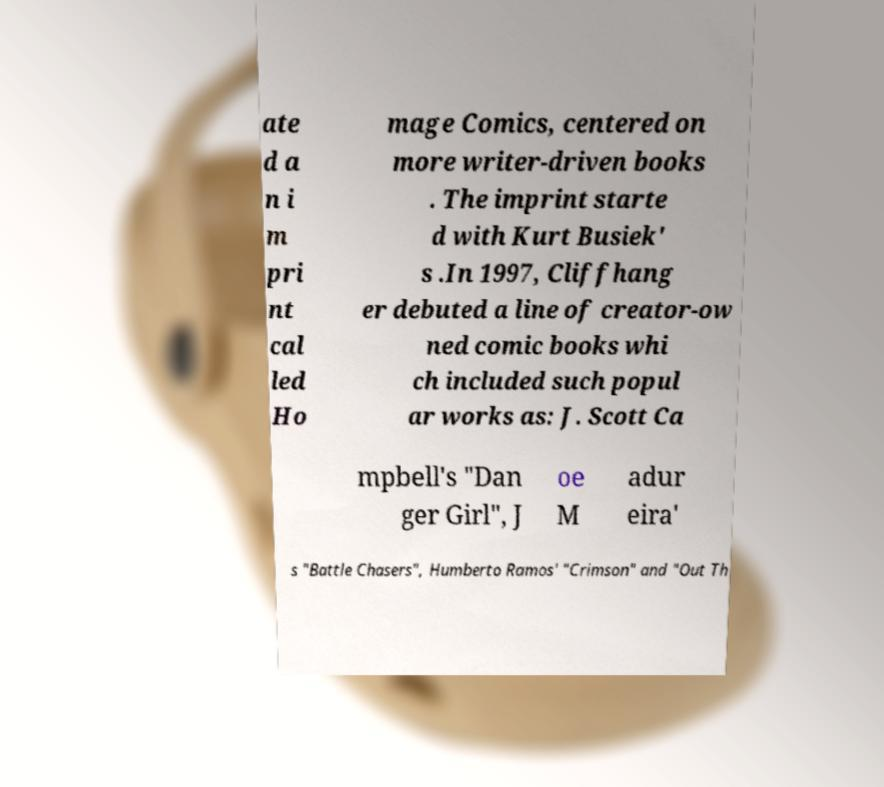Could you assist in decoding the text presented in this image and type it out clearly? ate d a n i m pri nt cal led Ho mage Comics, centered on more writer-driven books . The imprint starte d with Kurt Busiek' s .In 1997, Cliffhang er debuted a line of creator-ow ned comic books whi ch included such popul ar works as: J. Scott Ca mpbell's "Dan ger Girl", J oe M adur eira' s "Battle Chasers", Humberto Ramos' "Crimson" and "Out Th 